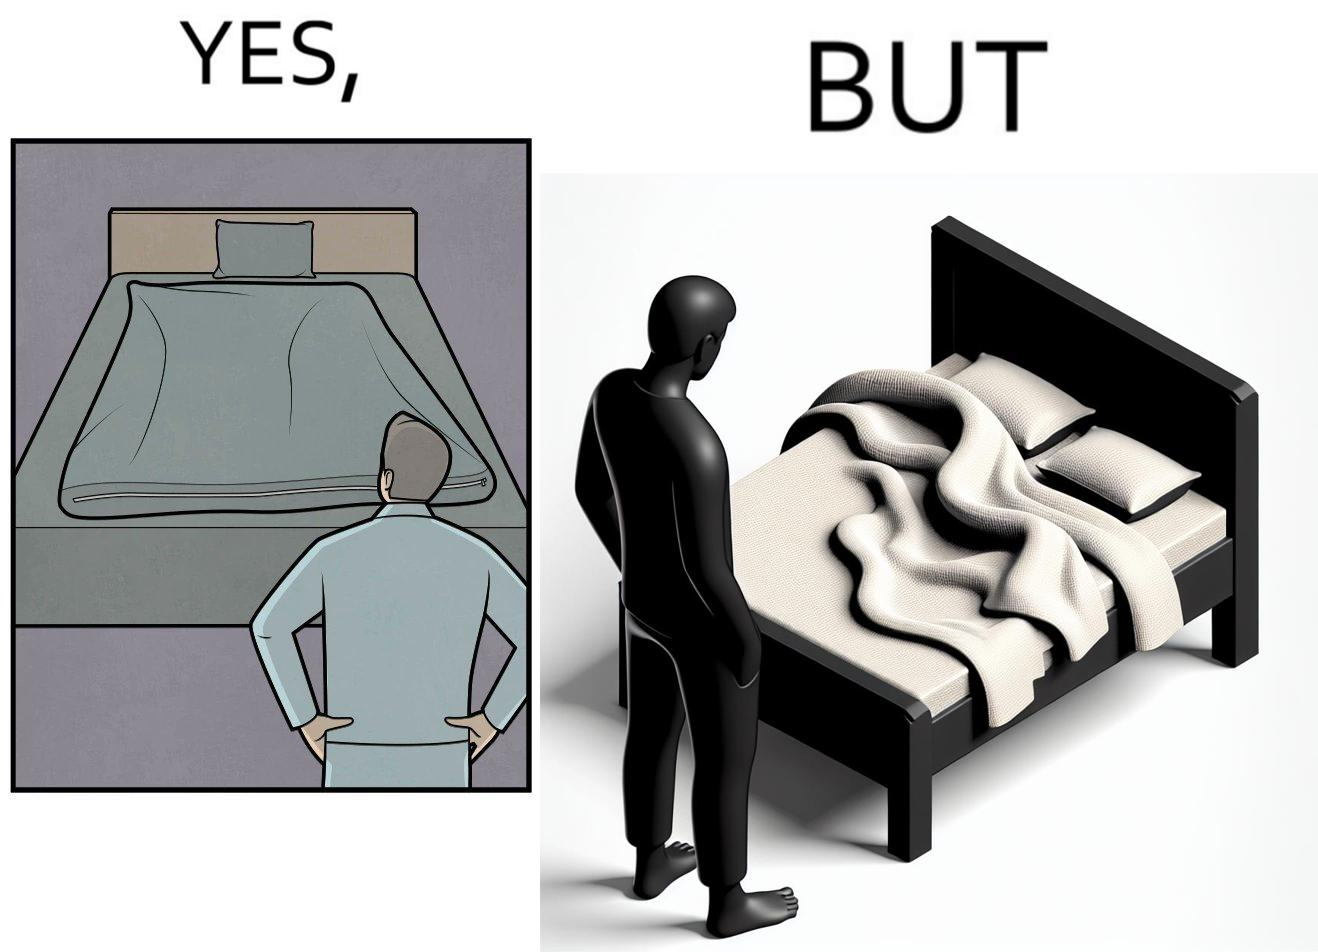Explain why this image is satirical. The image is funny because while the bed seems to be well made with the blanket on top, the actual blanket inside the blanket cover is twisted and not properly set. 